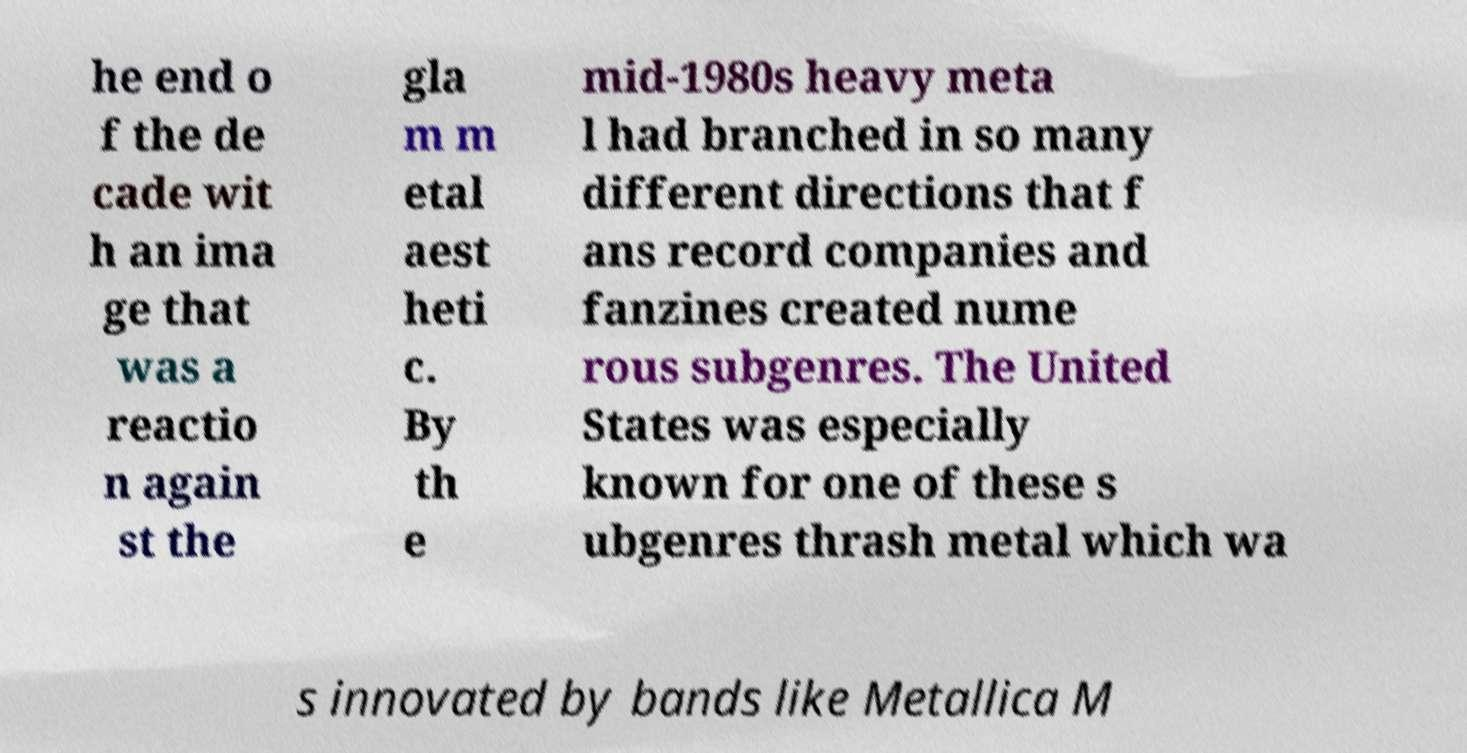There's text embedded in this image that I need extracted. Can you transcribe it verbatim? he end o f the de cade wit h an ima ge that was a reactio n again st the gla m m etal aest heti c. By th e mid-1980s heavy meta l had branched in so many different directions that f ans record companies and fanzines created nume rous subgenres. The United States was especially known for one of these s ubgenres thrash metal which wa s innovated by bands like Metallica M 